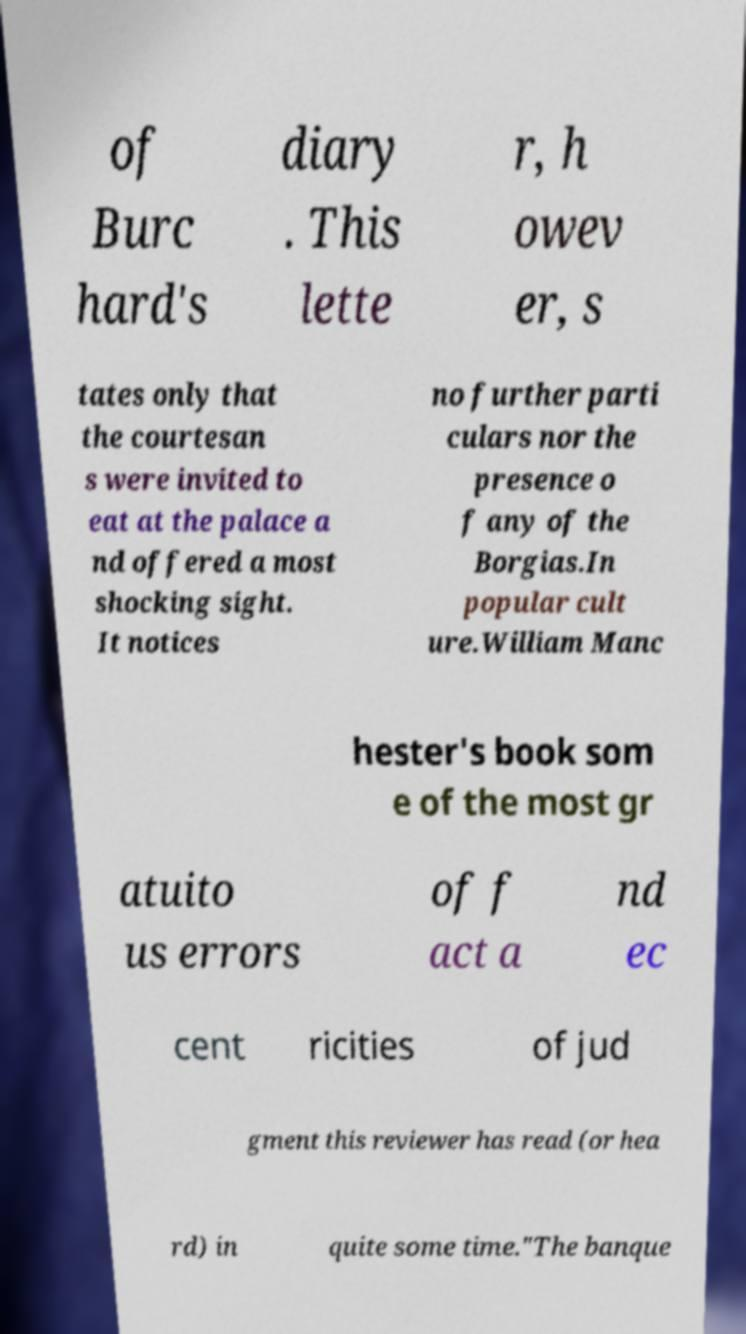For documentation purposes, I need the text within this image transcribed. Could you provide that? of Burc hard's diary . This lette r, h owev er, s tates only that the courtesan s were invited to eat at the palace a nd offered a most shocking sight. It notices no further parti culars nor the presence o f any of the Borgias.In popular cult ure.William Manc hester's book som e of the most gr atuito us errors of f act a nd ec cent ricities of jud gment this reviewer has read (or hea rd) in quite some time."The banque 